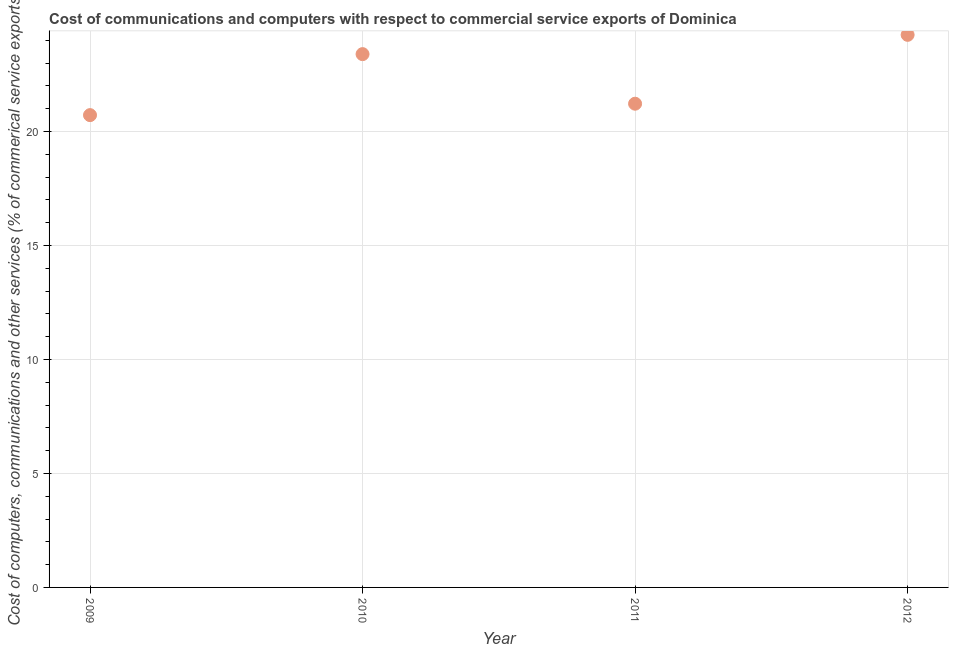What is the cost of communications in 2011?
Provide a short and direct response. 21.22. Across all years, what is the maximum cost of communications?
Provide a succinct answer. 24.24. Across all years, what is the minimum  computer and other services?
Offer a terse response. 20.72. What is the sum of the  computer and other services?
Make the answer very short. 89.57. What is the difference between the  computer and other services in 2009 and 2011?
Make the answer very short. -0.5. What is the average cost of communications per year?
Your answer should be very brief. 22.39. What is the median  computer and other services?
Your answer should be compact. 22.31. Do a majority of the years between 2009 and 2010 (inclusive) have  computer and other services greater than 22 %?
Your response must be concise. No. What is the ratio of the cost of communications in 2009 to that in 2011?
Offer a terse response. 0.98. Is the cost of communications in 2011 less than that in 2012?
Provide a succinct answer. Yes. Is the difference between the  computer and other services in 2010 and 2012 greater than the difference between any two years?
Keep it short and to the point. No. What is the difference between the highest and the second highest cost of communications?
Your answer should be very brief. 0.85. Is the sum of the  computer and other services in 2009 and 2012 greater than the maximum  computer and other services across all years?
Provide a succinct answer. Yes. What is the difference between the highest and the lowest cost of communications?
Give a very brief answer. 3.52. In how many years, is the  computer and other services greater than the average  computer and other services taken over all years?
Ensure brevity in your answer.  2. Does the  computer and other services monotonically increase over the years?
Make the answer very short. No. Are the values on the major ticks of Y-axis written in scientific E-notation?
Give a very brief answer. No. Does the graph contain any zero values?
Provide a succinct answer. No. What is the title of the graph?
Provide a succinct answer. Cost of communications and computers with respect to commercial service exports of Dominica. What is the label or title of the X-axis?
Your answer should be compact. Year. What is the label or title of the Y-axis?
Offer a very short reply. Cost of computers, communications and other services (% of commerical service exports). What is the Cost of computers, communications and other services (% of commerical service exports) in 2009?
Provide a succinct answer. 20.72. What is the Cost of computers, communications and other services (% of commerical service exports) in 2010?
Ensure brevity in your answer.  23.39. What is the Cost of computers, communications and other services (% of commerical service exports) in 2011?
Your answer should be very brief. 21.22. What is the Cost of computers, communications and other services (% of commerical service exports) in 2012?
Provide a succinct answer. 24.24. What is the difference between the Cost of computers, communications and other services (% of commerical service exports) in 2009 and 2010?
Offer a terse response. -2.68. What is the difference between the Cost of computers, communications and other services (% of commerical service exports) in 2009 and 2011?
Your response must be concise. -0.5. What is the difference between the Cost of computers, communications and other services (% of commerical service exports) in 2009 and 2012?
Ensure brevity in your answer.  -3.52. What is the difference between the Cost of computers, communications and other services (% of commerical service exports) in 2010 and 2011?
Your answer should be very brief. 2.18. What is the difference between the Cost of computers, communications and other services (% of commerical service exports) in 2010 and 2012?
Your answer should be compact. -0.85. What is the difference between the Cost of computers, communications and other services (% of commerical service exports) in 2011 and 2012?
Give a very brief answer. -3.02. What is the ratio of the Cost of computers, communications and other services (% of commerical service exports) in 2009 to that in 2010?
Your response must be concise. 0.89. What is the ratio of the Cost of computers, communications and other services (% of commerical service exports) in 2009 to that in 2012?
Your answer should be compact. 0.85. What is the ratio of the Cost of computers, communications and other services (% of commerical service exports) in 2010 to that in 2011?
Ensure brevity in your answer.  1.1. 